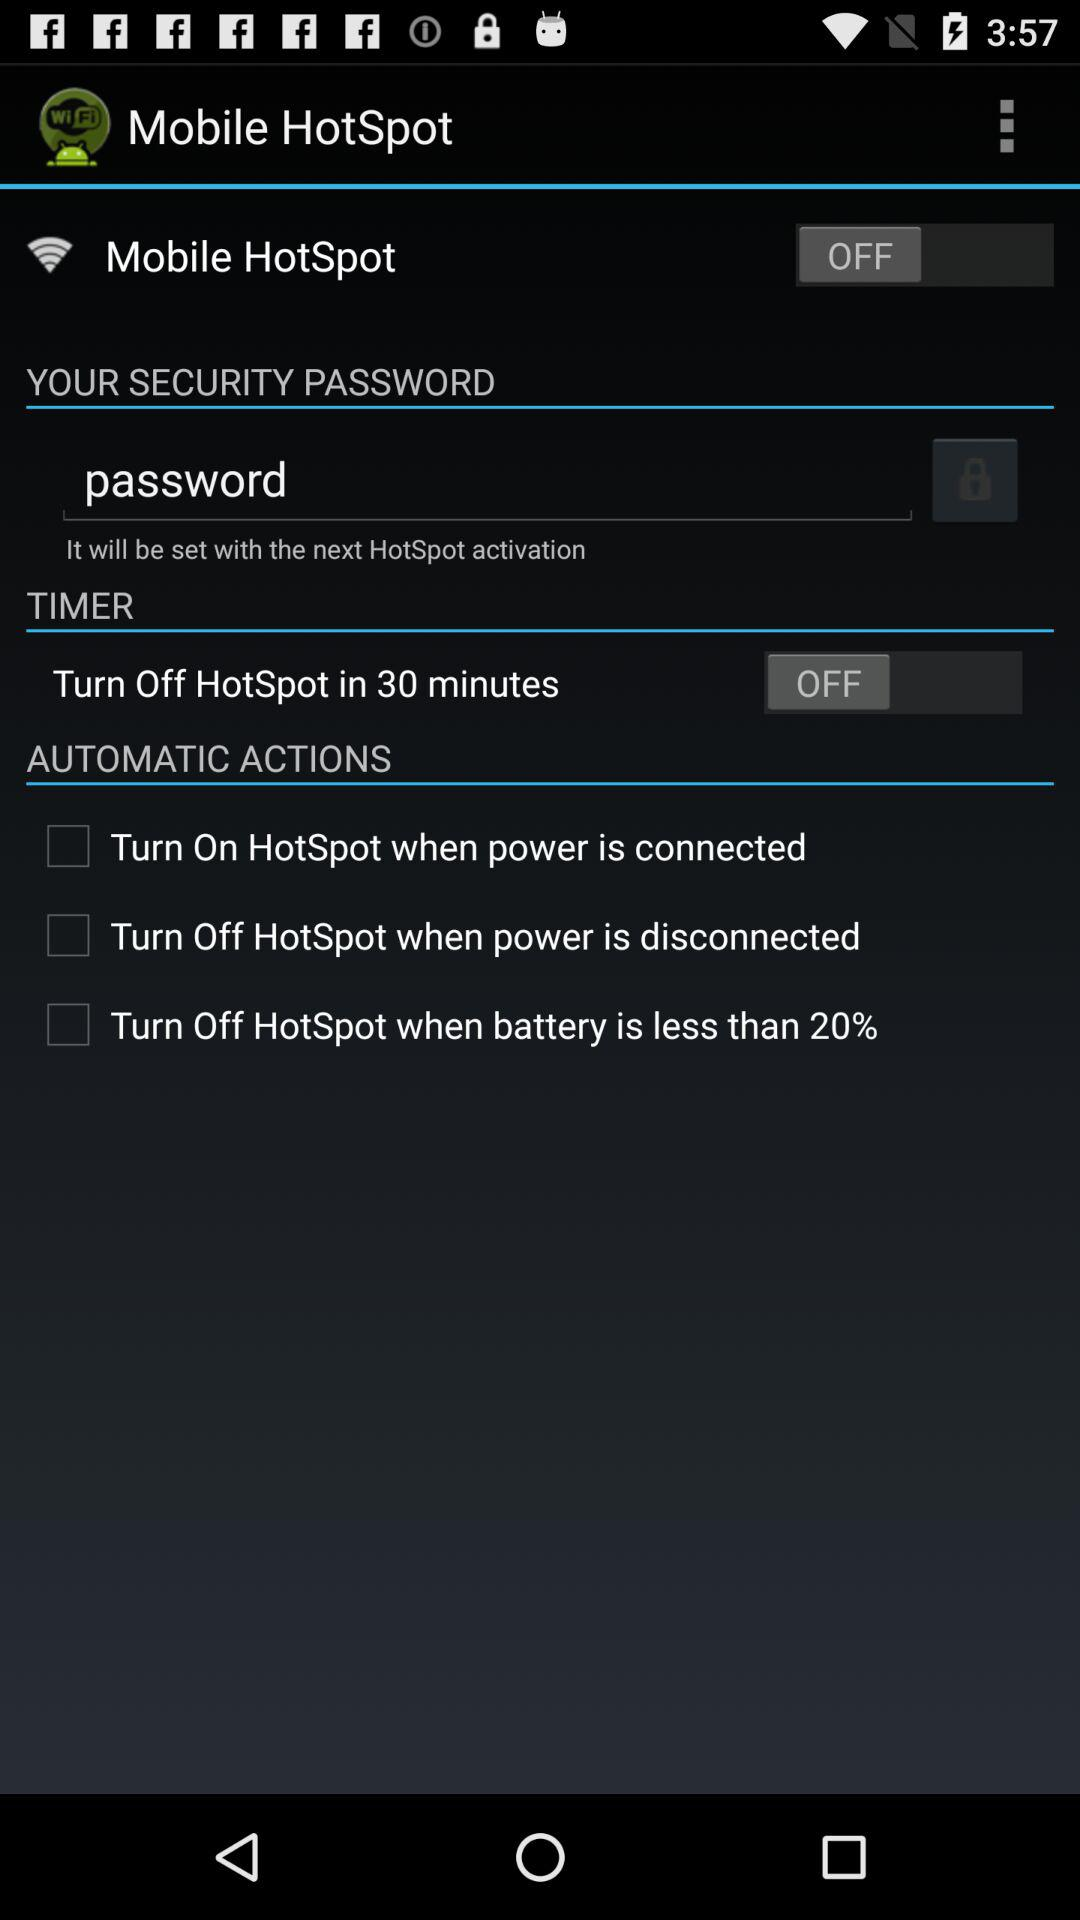How many more checkboxes are there than text inputs?
Answer the question using a single word or phrase. 2 